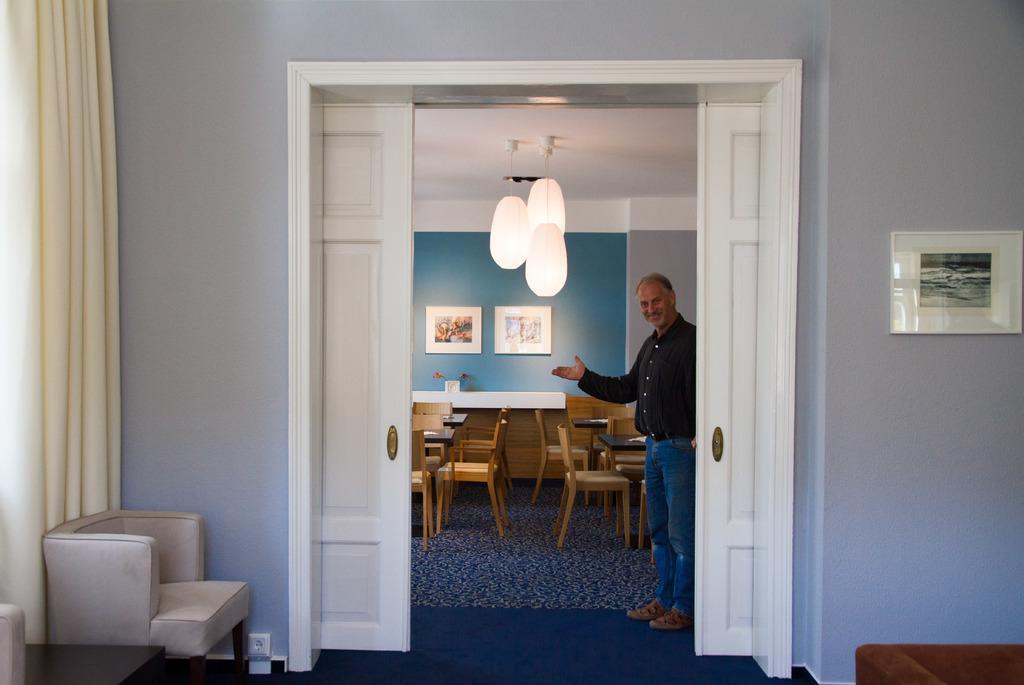Please provide a concise description of this image. This person standing and holding smile. On the background we can see wall,frames. On the top we can see lights. We can see tables and chairs,curtain. This is floor. 